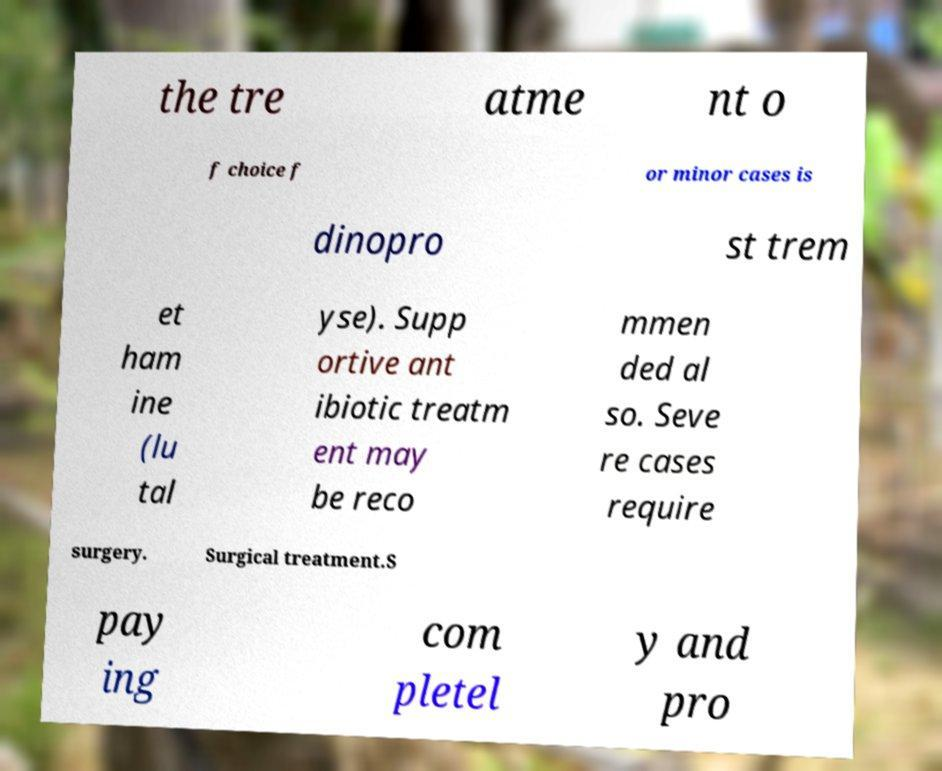Can you accurately transcribe the text from the provided image for me? the tre atme nt o f choice f or minor cases is dinopro st trem et ham ine (lu tal yse). Supp ortive ant ibiotic treatm ent may be reco mmen ded al so. Seve re cases require surgery. Surgical treatment.S pay ing com pletel y and pro 